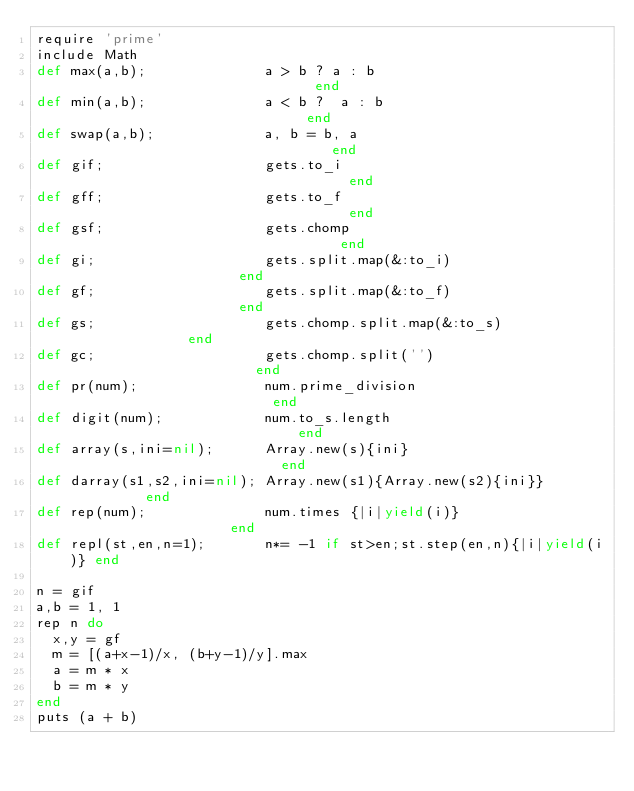<code> <loc_0><loc_0><loc_500><loc_500><_Ruby_>require 'prime'
include Math
def max(a,b);              a > b ? a : b                              end
def min(a,b);              a < b ?  a : b                             end
def swap(a,b);             a, b = b, a                                end
def gif;                   gets.to_i                                  end
def gff;                   gets.to_f                                  end
def gsf;                   gets.chomp                                 end
def gi;                    gets.split.map(&:to_i)                     end
def gf;                    gets.split.map(&:to_f)                     end
def gs;                    gets.chomp.split.map(&:to_s)               end
def gc;                    gets.chomp.split('')                       end
def pr(num);               num.prime_division                         end
def digit(num);            num.to_s.length                            end
def array(s,ini=nil);      Array.new(s){ini}                          end
def darray(s1,s2,ini=nil); Array.new(s1){Array.new(s2){ini}}          end
def rep(num);              num.times {|i|yield(i)}                    end
def repl(st,en,n=1);       n*= -1 if st>en;st.step(en,n){|i|yield(i)} end

n = gif
a,b = 1, 1
rep n do
  x,y = gf
  m = [(a+x-1)/x, (b+y-1)/y].max
  a = m * x
  b = m * y
end
puts (a + b)
</code> 